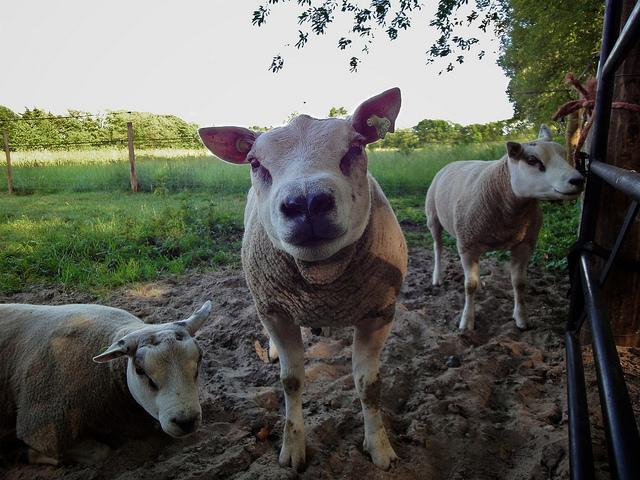How many weird looking sheeps are standing on top of the dirt pile?

Choices:
A) two
B) three
C) four
D) one three 